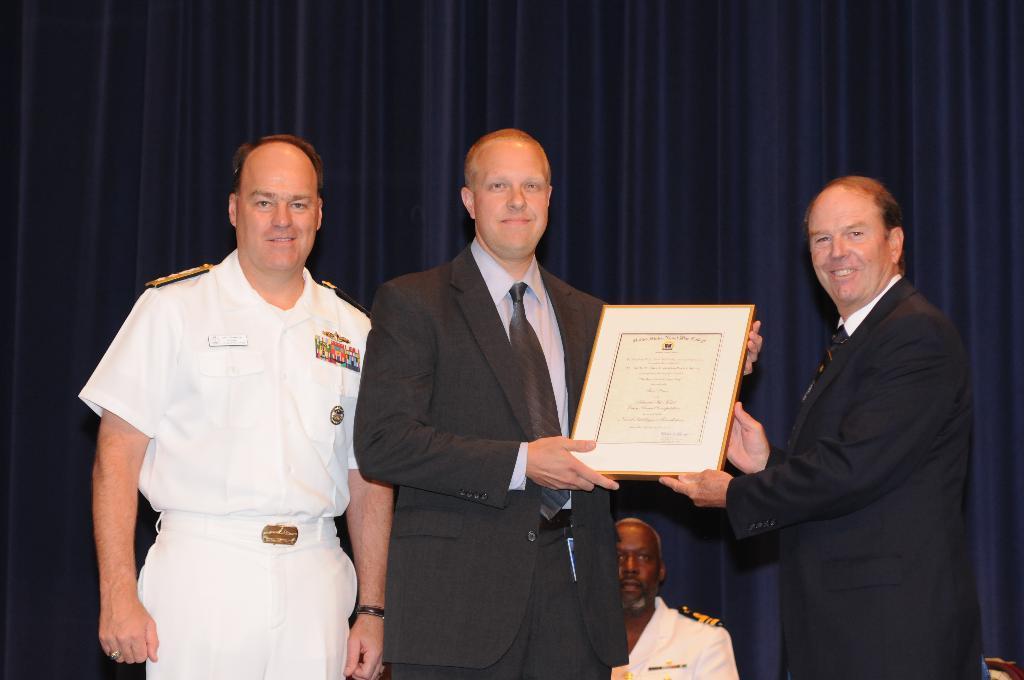In one or two sentences, can you explain what this image depicts? In the center of the image three mans are standing, two of them are holding a certificate in there hands. At the bottom of the image a man is there. In the background of the image we can see a curtain. 